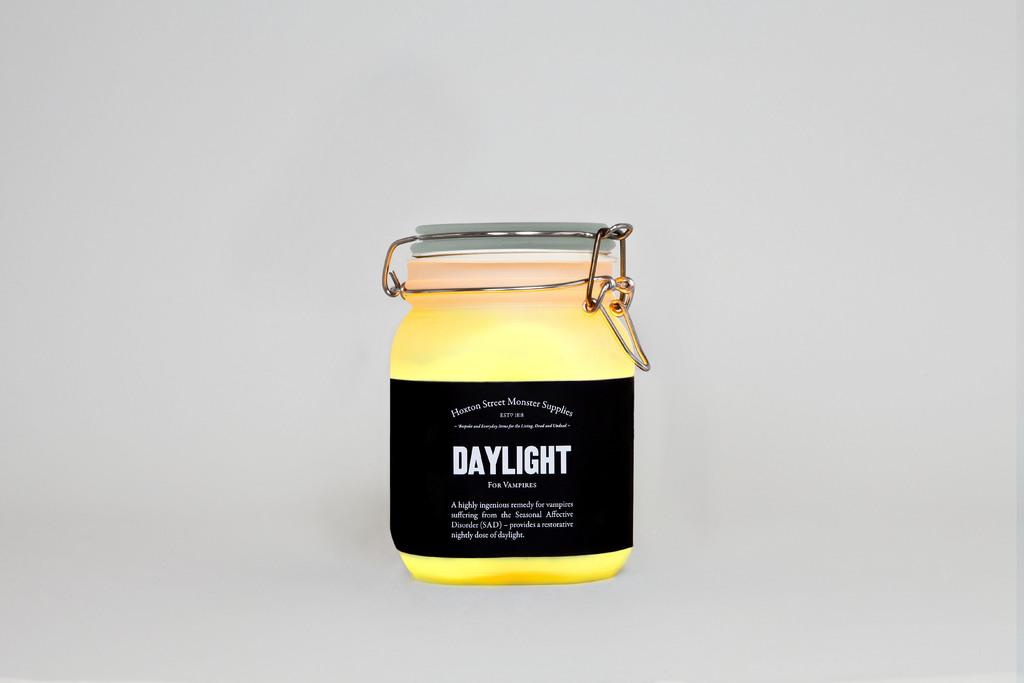<image>
Provide a brief description of the given image. A jar has a black label and the word daylight on it. 